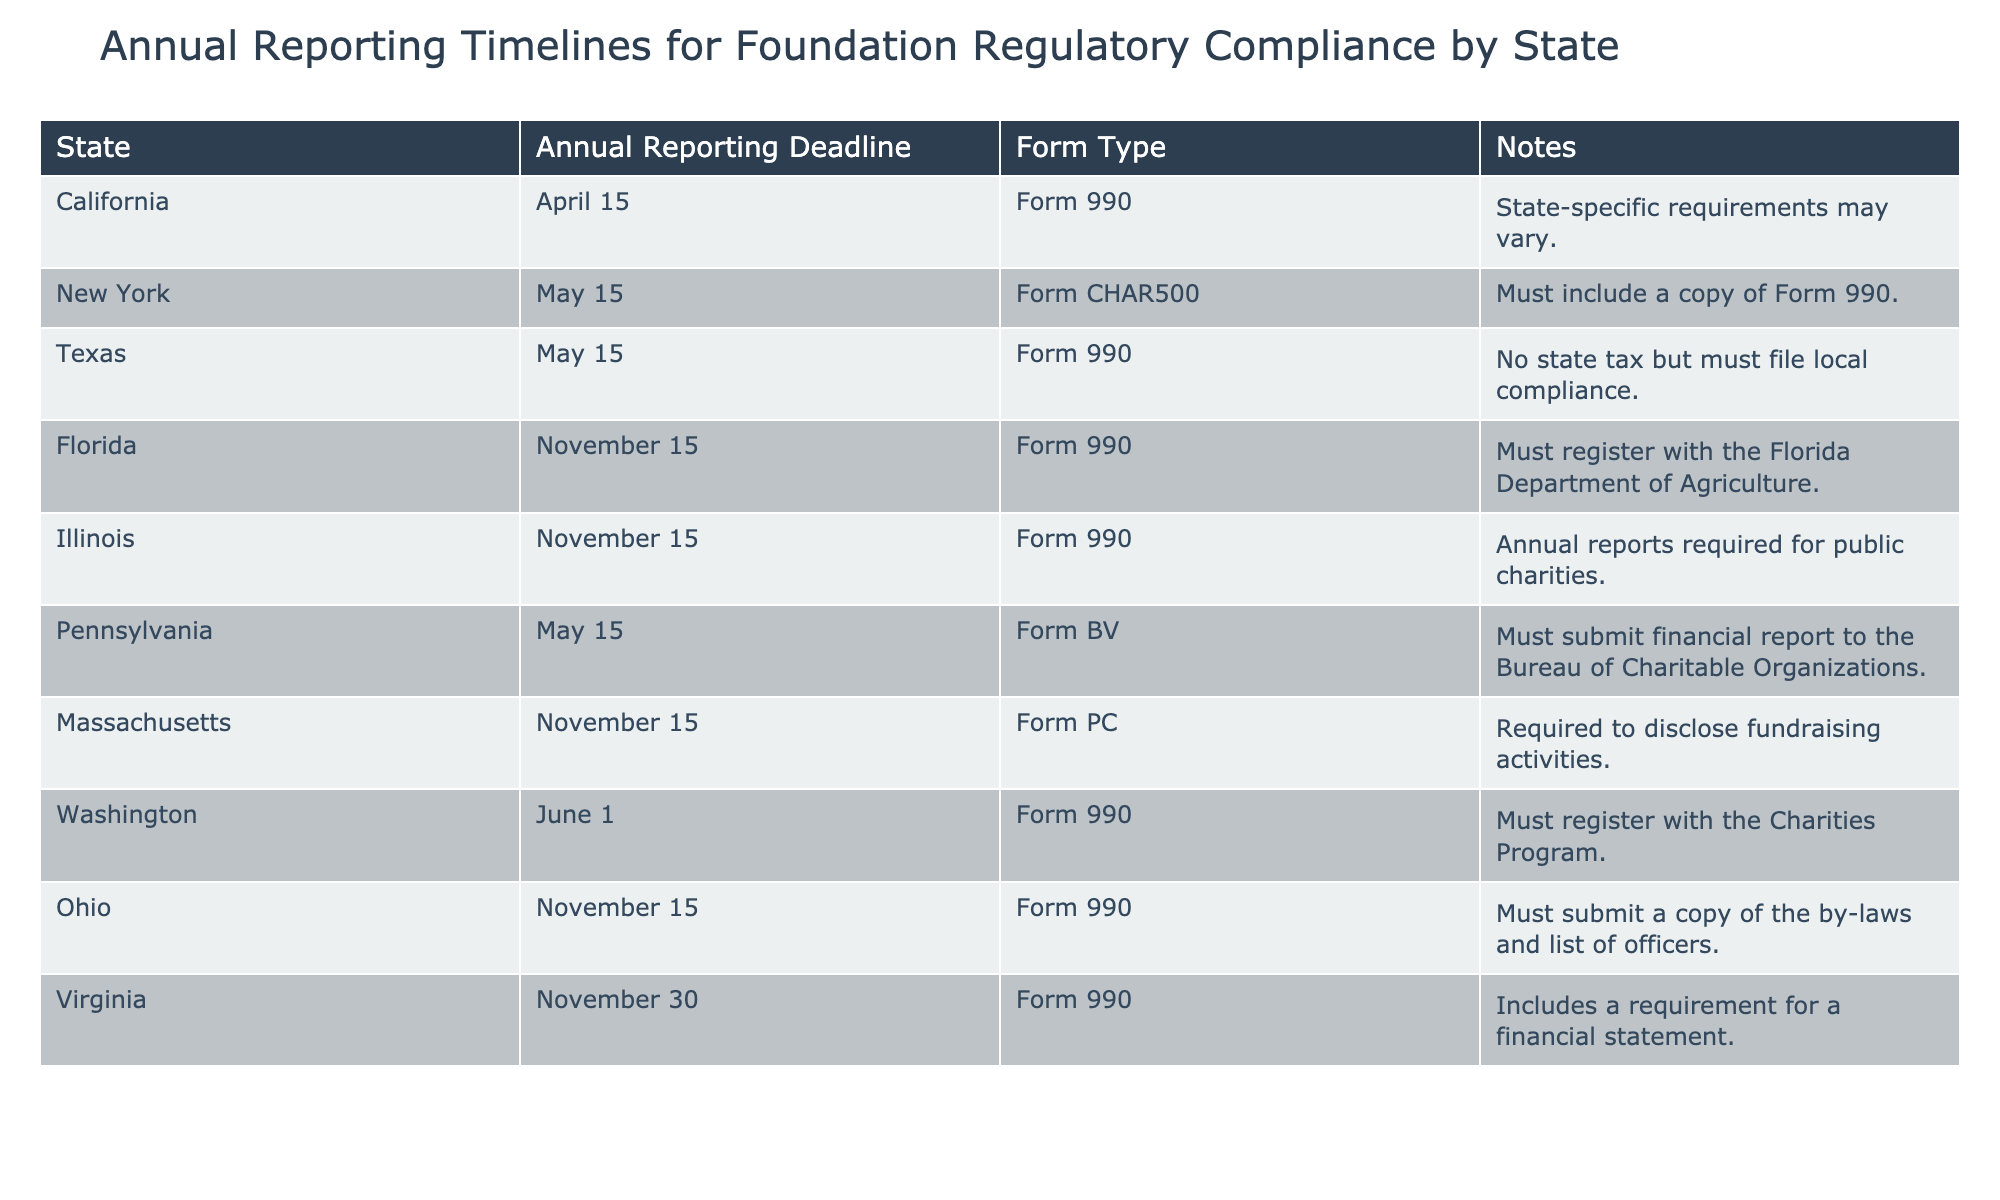What is the annual reporting deadline for California? The table indicates that the annual reporting deadline for California is April 15.
Answer: April 15 Which state requires the submission of a copy of Form 990 along with its annual filing? According to the table, New York requires a copy of Form 990 to be submitted along with its filing.
Answer: New York How many states have an annual reporting deadline in November? The table lists five states (Florida, Illinois, Massachusetts, Ohio, Virginia) with a November deadline, so the count is five.
Answer: 5 Is the annual reporting deadline for Texas the same as for New York? The table shows that Texas has a deadline of May 15, while New York also has a deadline of May 15. Since both states have the same deadline, the answer is yes.
Answer: Yes Which form type is required by Pennsylvania for annual reporting? The table specifies that Pennsylvania requires Form BV for annual reporting.
Answer: Form BV What is the latest deadline among the listed states for annual reporting? Among the annual reporting deadlines listed, November 30 (Virginia) is the latest compared to others, so it is the answer.
Answer: November 30 How many states require Form 990 for annual reporting? The table shows that California, Texas, Florida, Illinois, Ohio, and Virginia require Form 990, making a total of six states.
Answer: 6 Is it true that Florida must register with the Department of Agriculture for compliance? According to the table, Florida must register with the Florida Department of Agriculture, making this statement true.
Answer: True What is the average deadline day for the annual reporting across all states? To determine the average: convert the deadlines into days; April 15 (105), May 15 (135), November 15 (319), June 1 (152), November 30 (334). Sum is 1,184 and divide by 10 states to get an average of approximately 118.4, which rounds to 118 (using just days).
Answer: 118 (average day) 